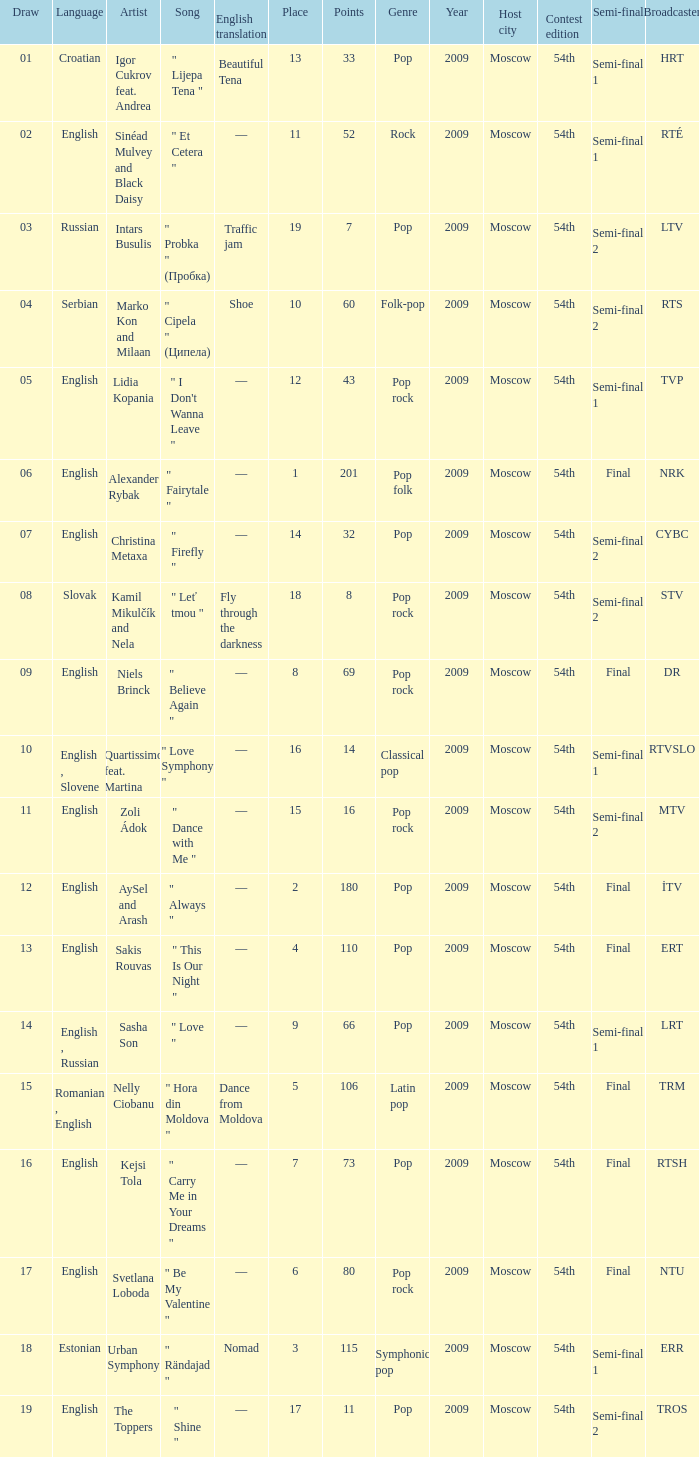Can you parse all the data within this table? {'header': ['Draw', 'Language', 'Artist', 'Song', 'English translation', 'Place', 'Points', 'Genre', 'Year', 'Host city', 'Contest edition', 'Semi-final', 'Broadcaster'], 'rows': [['01', 'Croatian', 'Igor Cukrov feat. Andrea', '" Lijepa Tena "', 'Beautiful Tena', '13', '33', 'Pop', '2009', 'Moscow', '54th', 'Semi-final 1', 'HRT'], ['02', 'English', 'Sinéad Mulvey and Black Daisy', '" Et Cetera "', '—', '11', '52', 'Rock', '2009', 'Moscow', '54th', 'Semi-final 1', 'RTÉ'], ['03', 'Russian', 'Intars Busulis', '" Probka " (Пробка)', 'Traffic jam', '19', '7', 'Pop', '2009', 'Moscow', '54th', 'Semi-final 2', 'LTV'], ['04', 'Serbian', 'Marko Kon and Milaan', '" Cipela " (Ципела)', 'Shoe', '10', '60', 'Folk-pop', '2009', 'Moscow', '54th', 'Semi-final 2', 'RTS'], ['05', 'English', 'Lidia Kopania', '" I Don\'t Wanna Leave "', '—', '12', '43', 'Pop rock', '2009', 'Moscow', '54th', 'Semi-final 1', 'TVP'], ['06', 'English', 'Alexander Rybak', '" Fairytale "', '—', '1', '201', 'Pop folk', '2009', 'Moscow', '54th', 'Final', 'NRK'], ['07', 'English', 'Christina Metaxa', '" Firefly "', '—', '14', '32', 'Pop', '2009', 'Moscow', '54th', 'Semi-final 2', 'CYBC'], ['08', 'Slovak', 'Kamil Mikulčík and Nela', '" Leť tmou "', 'Fly through the darkness', '18', '8', 'Pop rock', '2009', 'Moscow', '54th', 'Semi-final 2', 'STV'], ['09', 'English', 'Niels Brinck', '" Believe Again "', '—', '8', '69', 'Pop rock', '2009', 'Moscow', '54th', 'Final', 'DR'], ['10', 'English , Slovene', 'Quartissimo feat. Martina', '" Love Symphony "', '—', '16', '14', 'Classical pop', '2009', 'Moscow', '54th', 'Semi-final 1', 'RTVSLO'], ['11', 'English', 'Zoli Ádok', '" Dance with Me "', '—', '15', '16', 'Pop rock', '2009', 'Moscow', '54th', 'Semi-final 2', 'MTV'], ['12', 'English', 'AySel and Arash', '" Always "', '—', '2', '180', 'Pop', '2009', 'Moscow', '54th', 'Final', 'İTV'], ['13', 'English', 'Sakis Rouvas', '" This Is Our Night "', '—', '4', '110', 'Pop', '2009', 'Moscow', '54th', 'Final', 'ERT'], ['14', 'English , Russian', 'Sasha Son', '" Love "', '—', '9', '66', 'Pop', '2009', 'Moscow', '54th', 'Semi-final 1', 'LRT'], ['15', 'Romanian , English', 'Nelly Ciobanu', '" Hora din Moldova "', 'Dance from Moldova', '5', '106', 'Latin pop', '2009', 'Moscow', '54th', 'Final', 'TRM'], ['16', 'English', 'Kejsi Tola', '" Carry Me in Your Dreams "', '—', '7', '73', 'Pop', '2009', 'Moscow', '54th', 'Final', 'RTSH'], ['17', 'English', 'Svetlana Loboda', '" Be My Valentine "', '—', '6', '80', 'Pop rock', '2009', 'Moscow', '54th', 'Final', 'NTU'], ['18', 'Estonian', 'Urban Symphony', '" Rändajad "', 'Nomad', '3', '115', 'Symphonic pop', '2009', 'Moscow', '54th', 'Semi-final 1', 'ERR'], ['19', 'English', 'The Toppers', '" Shine "', '—', '17', '11', 'Pop', '2009', 'Moscow', '54th', 'Semi-final 2', 'TROS']]} What is the english translation when the language is english, draw is smaller than 16, and the artist is aysel and arash? —. 